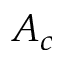Convert formula to latex. <formula><loc_0><loc_0><loc_500><loc_500>A _ { c }</formula> 